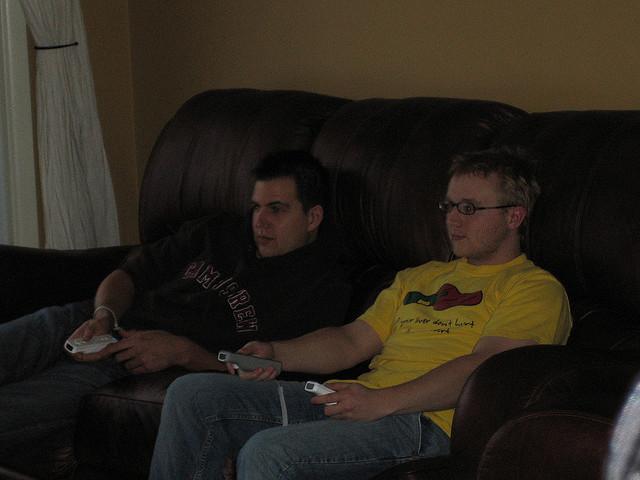What color is the man's skin?
Keep it brief. White. What fruit is pictured on the man's shirt?
Give a very brief answer. None. Are these two people close to the same age?
Be succinct. Yes. Is this guy wearing a short-sleeved shirt?
Answer briefly. Yes. What is on the couch?
Write a very short answer. People. What is on the couch beside the man?
Write a very short answer. Man. Are these people sitting in a chair?
Answer briefly. Yes. What is this person holding?
Give a very brief answer. Remote. What is the man doing?
Quick response, please. Playing wii. Is there enough room for him to sit up all the way?
Quick response, please. Yes. Is the man laying across a bed?
Give a very brief answer. No. What is this person's favorite baseball team?
Short answer required. Red sox. How many rings is the man wearing?
Answer briefly. 0. Can you see the people's face?
Concise answer only. Yes. What kind of shirt is this?
Give a very brief answer. T-shirt. How many people are wearing glasses?
Write a very short answer. 1. What is the man holding in his left hand?
Short answer required. Controller. Where are they laying?
Be succinct. Couch. What game system are the guys playing?
Quick response, please. Wii. How many curtains are there?
Concise answer only. 1. Do these guys look lazy?
Keep it brief. Yes. Does he have a beard?
Short answer required. No. How is this couch upholstered?
Keep it brief. Leather. What color is the man's hair?
Short answer required. Brown. What is the holding?
Write a very short answer. Wii remote. 